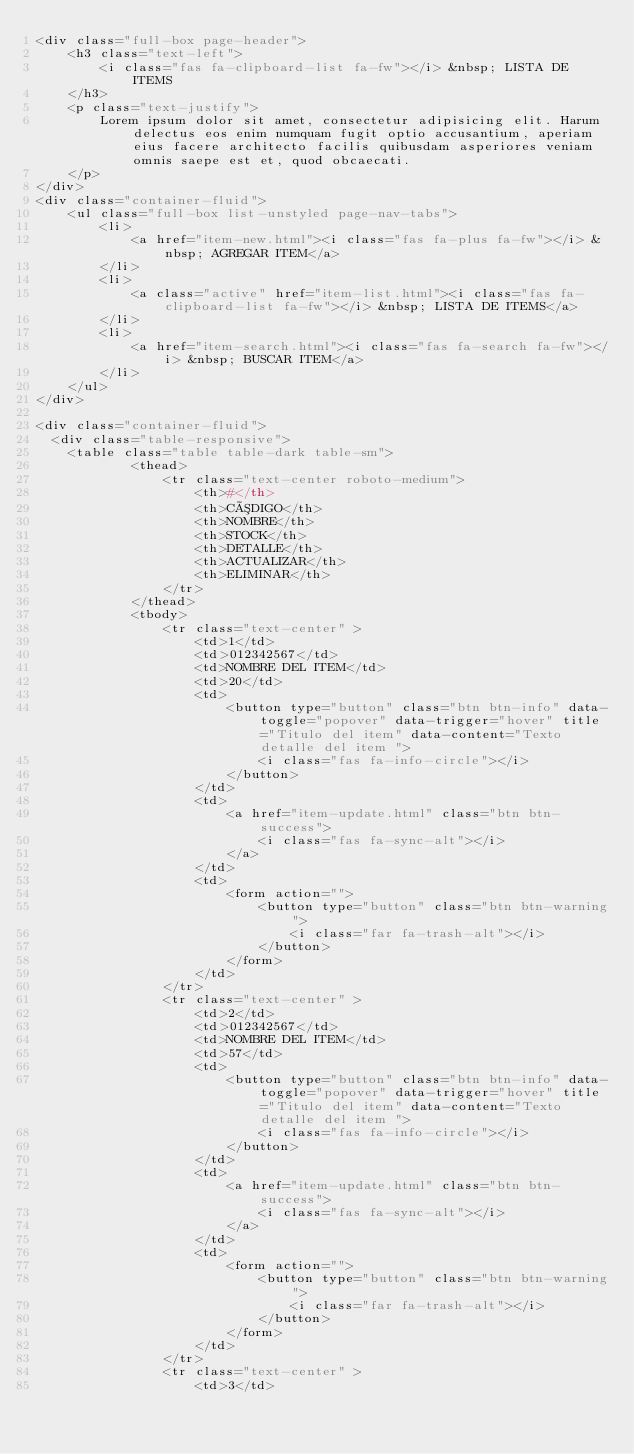<code> <loc_0><loc_0><loc_500><loc_500><_PHP_><div class="full-box page-header">
    <h3 class="text-left">
        <i class="fas fa-clipboard-list fa-fw"></i> &nbsp; LISTA DE ITEMS
    </h3>
    <p class="text-justify">
        Lorem ipsum dolor sit amet, consectetur adipisicing elit. Harum delectus eos enim numquam fugit optio accusantium, aperiam eius facere architecto facilis quibusdam asperiores veniam omnis saepe est et, quod obcaecati.
    </p>
</div>
<div class="container-fluid">
    <ul class="full-box list-unstyled page-nav-tabs">
        <li>
            <a href="item-new.html"><i class="fas fa-plus fa-fw"></i> &nbsp; AGREGAR ITEM</a>
        </li>
        <li>
            <a class="active" href="item-list.html"><i class="fas fa-clipboard-list fa-fw"></i> &nbsp; LISTA DE ITEMS</a>
        </li>
        <li>
            <a href="item-search.html"><i class="fas fa-search fa-fw"></i> &nbsp; BUSCAR ITEM</a>
        </li>
    </ul>
</div>

<div class="container-fluid">
	<div class="table-responsive">
		<table class="table table-dark table-sm">
            <thead>
                <tr class="text-center roboto-medium">
                    <th>#</th>
                    <th>CÓDIGO</th>
                    <th>NOMBRE</th>
                    <th>STOCK</th>
                    <th>DETALLE</th>
                    <th>ACTUALIZAR</th>
                    <th>ELIMINAR</th>
                </tr>
            </thead>
            <tbody>
                <tr class="text-center" >
                    <td>1</td>
                    <td>012342567</td>
                    <td>NOMBRE DEL ITEM</td>
                    <td>20</td>
                    <td>
                        <button type="button" class="btn btn-info" data-toggle="popover" data-trigger="hover" title="Titulo del item" data-content="Texto detalle del item ">
                            <i class="fas fa-info-circle"></i>
                        </button>
                    </td>
                    <td>
                        <a href="item-update.html" class="btn btn-success">
                            <i class="fas fa-sync-alt"></i> 
                        </a>
                    </td>
                    <td>
                        <form action="">
                            <button type="button" class="btn btn-warning">
                                <i class="far fa-trash-alt"></i>
                            </button>
                        </form>
                    </td>
                </tr>
                <tr class="text-center" >
                    <td>2</td>
                    <td>012342567</td>
                    <td>NOMBRE DEL ITEM</td>
                    <td>57</td>
                    <td>
                        <button type="button" class="btn btn-info" data-toggle="popover" data-trigger="hover" title="Titulo del item" data-content="Texto detalle del item ">
                            <i class="fas fa-info-circle"></i>
                        </button>
                    </td>
                    <td>
                        <a href="item-update.html" class="btn btn-success">
                            <i class="fas fa-sync-alt"></i> 
                        </a>
                    </td>
                    <td>
                        <form action="">
                            <button type="button" class="btn btn-warning">
                                <i class="far fa-trash-alt"></i>
                            </button>
                        </form>
                    </td>
                </tr>
                <tr class="text-center" >
                    <td>3</td></code> 